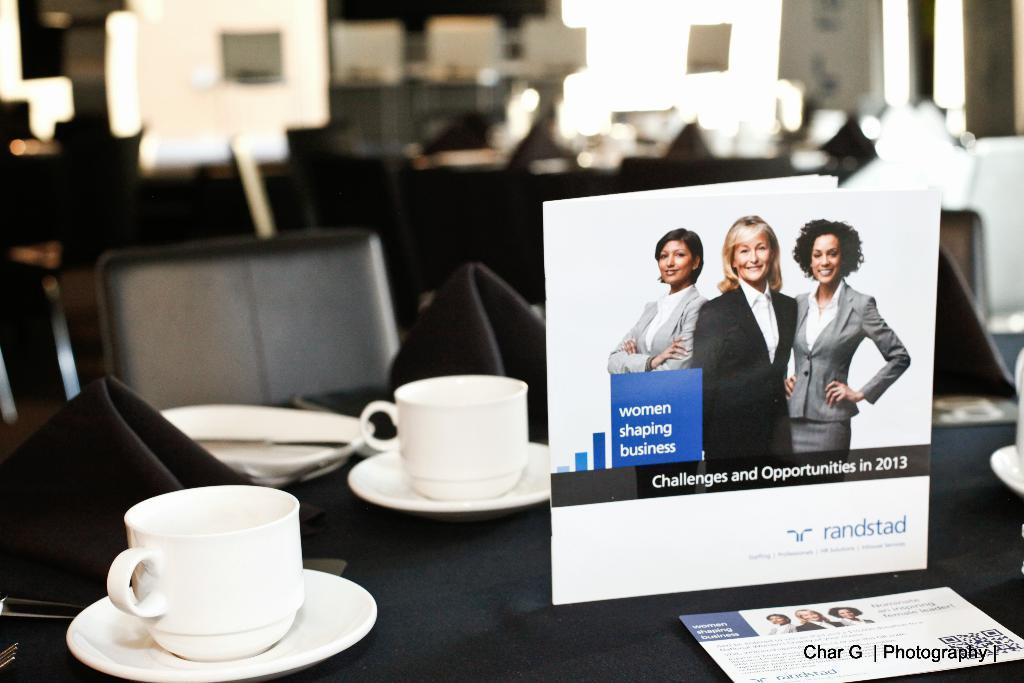Can you describe this image briefly? In this image there is one table and on the table there is one cloth and cups and saucers are there on the table. On the right side of the table there is one paper on the right side of the background of the image there is one glass window on the left side there is one wall and some chairs are there. 